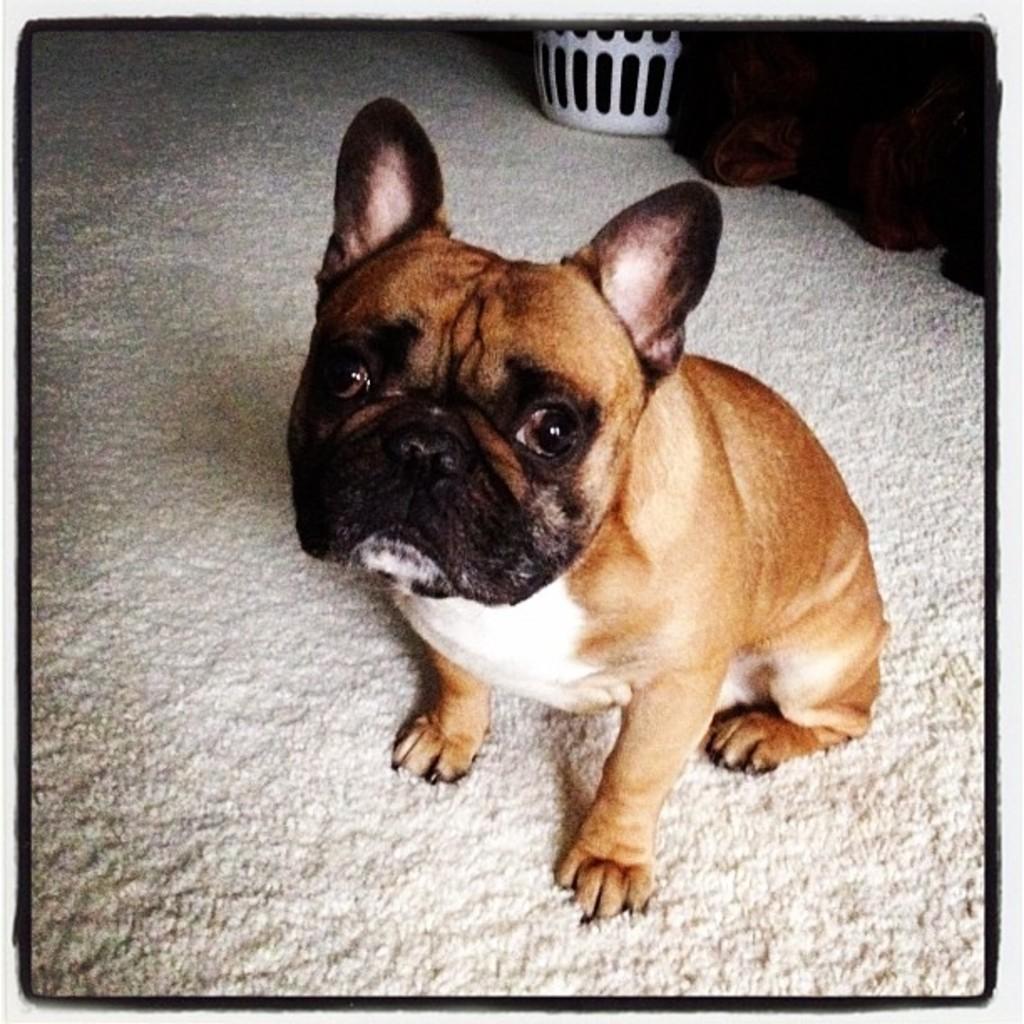Describe this image in one or two sentences. In this image I can see a dog in brown, black and white color. Background I can see an object in white color. 